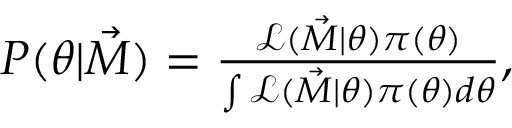Convert formula to latex. <formula><loc_0><loc_0><loc_500><loc_500>\begin{array} { r } { P ( \theta | \vec { M } ) = \frac { \mathcal { L } ( \vec { M } | \theta ) \pi ( \theta ) } { \int \mathcal { L } ( \vec { M } | \theta ) \pi ( \theta ) d \theta } , } \end{array}</formula> 